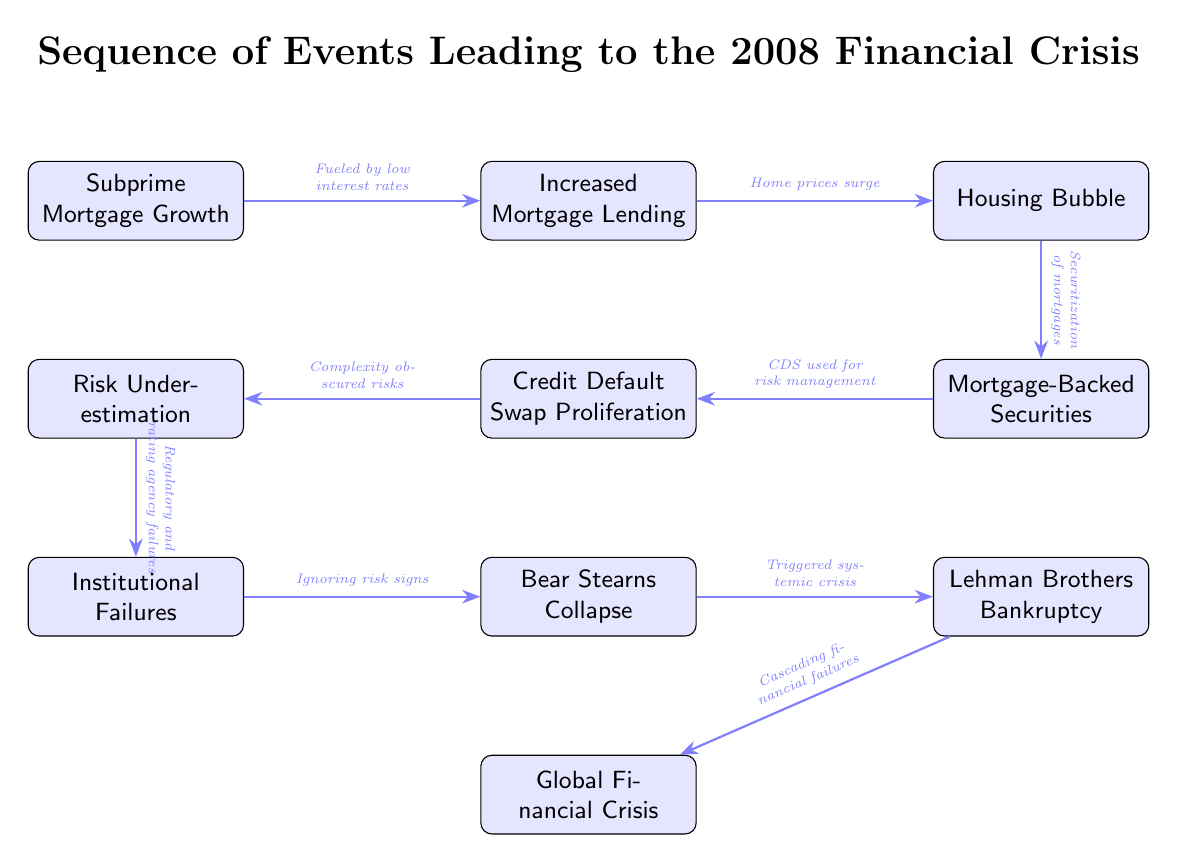What is the first event in the sequence? The first event in the sequence, based on the diagram, is "Subprime Mortgage Growth," as it appears at the top of the flowchart.
Answer: Subprime Mortgage Growth How many events are shown in the diagram? By counting the nodes in the diagram, there are a total of ten events depicted in the sequence.
Answer: Ten Which two events are directly linked by an arrow? An example of two directly linked events in the diagram is "Increased Mortgage Lending" and "Housing Bubble," which have an arrow indicating a relationship between them.
Answer: Increased Mortgage Lending and Housing Bubble What is the role of Credit Default Swaps in this sequence? The role of Credit Default Swaps (CDS) is indicated as "CDS used for risk management," showing their use in the financial framework before the crisis unfolded.
Answer: CDS used for risk management What event follows "Risk Underestimation"? The event that directly follows "Risk Underestimation" in the flow of the diagram is "Institutional Failures," connected by an arrow.
Answer: Institutional Failures What describes the relationship between "Bear Stearns Collapse" and "Lehman Brothers Bankruptcy"? The relationship is described as "Triggered systemic crisis," indicating that the collapse of Bear Stearns had an impact on the subsequent bankruptcy of Lehman Brothers.
Answer: Triggered systemic crisis What fuels the subprime mortgage growth? The fuel for the subprime mortgage growth is identified in the diagram as "Fueled by low interest rates," which highlights an economic condition contributing to this growth.
Answer: Fueled by low interest rates What leads to the cascading financial failures? The cascading financial failures are a result of the "Lehman Brothers Bankruptcy," as indicated by the arrow connecting these two events in the diagram.
Answer: Lehman Brothers Bankruptcy What is the final event in the sequence? The final event in the sequence is "Global Financial Crisis," which is positioned at the bottom of the diagram and represents the outcome of the preceding events.
Answer: Global Financial Crisis 